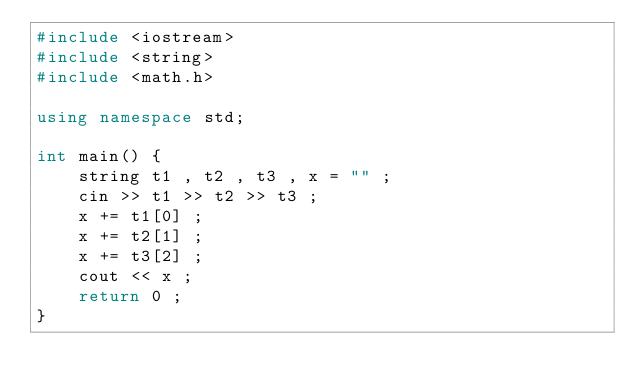<code> <loc_0><loc_0><loc_500><loc_500><_C++_>#include <iostream>
#include <string>
#include <math.h>

using namespace std;

int main() {
    string t1 , t2 , t3 , x = "" ;
    cin >> t1 >> t2 >> t3 ;
    x += t1[0] ;
    x += t2[1] ;
    x += t3[2] ;
    cout << x ;
    return 0 ;
}
</code> 